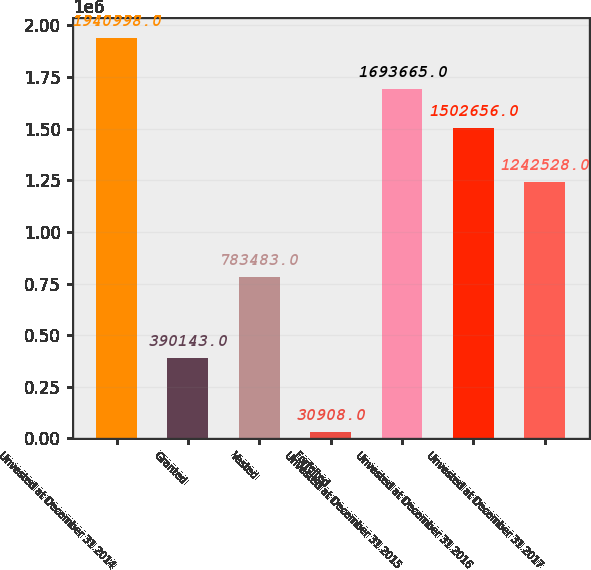Convert chart to OTSL. <chart><loc_0><loc_0><loc_500><loc_500><bar_chart><fcel>Unvested at December 31 2014<fcel>Granted<fcel>Vested<fcel>Forfeited<fcel>Unvested at December 31 2015<fcel>Unvested at December 31 2016<fcel>Unvested at December 31 2017<nl><fcel>1.941e+06<fcel>390143<fcel>783483<fcel>30908<fcel>1.69366e+06<fcel>1.50266e+06<fcel>1.24253e+06<nl></chart> 